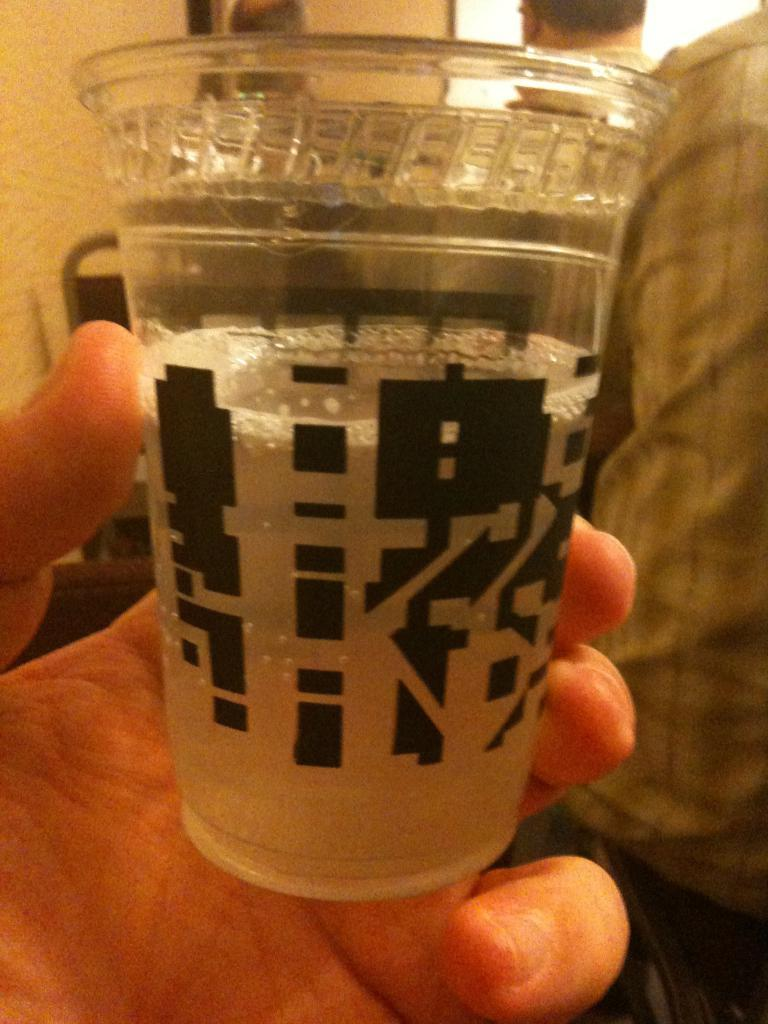What is the person in the image holding? The person is holding a glass in the image. Can you describe the setting of the image? There are other people visible in the background of the image, and the background has a cream color. What type of toothpaste is the person using in the image? There is no toothpaste present in the image; the person is holding a glass. 